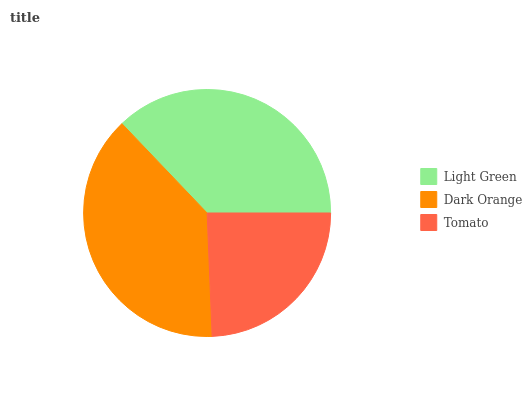Is Tomato the minimum?
Answer yes or no. Yes. Is Dark Orange the maximum?
Answer yes or no. Yes. Is Dark Orange the minimum?
Answer yes or no. No. Is Tomato the maximum?
Answer yes or no. No. Is Dark Orange greater than Tomato?
Answer yes or no. Yes. Is Tomato less than Dark Orange?
Answer yes or no. Yes. Is Tomato greater than Dark Orange?
Answer yes or no. No. Is Dark Orange less than Tomato?
Answer yes or no. No. Is Light Green the high median?
Answer yes or no. Yes. Is Light Green the low median?
Answer yes or no. Yes. Is Tomato the high median?
Answer yes or no. No. Is Dark Orange the low median?
Answer yes or no. No. 